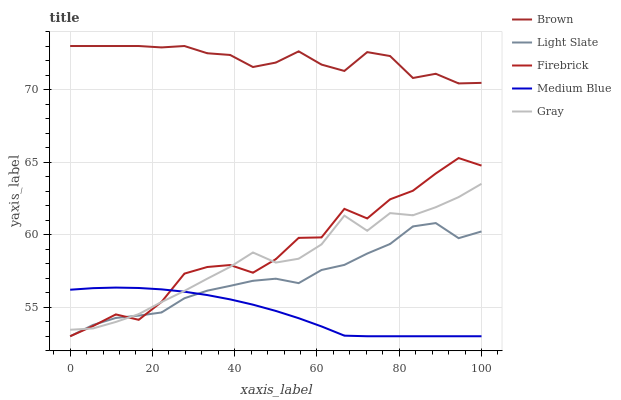Does Medium Blue have the minimum area under the curve?
Answer yes or no. Yes. Does Brown have the maximum area under the curve?
Answer yes or no. Yes. Does Firebrick have the minimum area under the curve?
Answer yes or no. No. Does Firebrick have the maximum area under the curve?
Answer yes or no. No. Is Medium Blue the smoothest?
Answer yes or no. Yes. Is Firebrick the roughest?
Answer yes or no. Yes. Is Brown the smoothest?
Answer yes or no. No. Is Brown the roughest?
Answer yes or no. No. Does Light Slate have the lowest value?
Answer yes or no. Yes. Does Brown have the lowest value?
Answer yes or no. No. Does Brown have the highest value?
Answer yes or no. Yes. Does Firebrick have the highest value?
Answer yes or no. No. Is Firebrick less than Brown?
Answer yes or no. Yes. Is Brown greater than Light Slate?
Answer yes or no. Yes. Does Gray intersect Medium Blue?
Answer yes or no. Yes. Is Gray less than Medium Blue?
Answer yes or no. No. Is Gray greater than Medium Blue?
Answer yes or no. No. Does Firebrick intersect Brown?
Answer yes or no. No. 